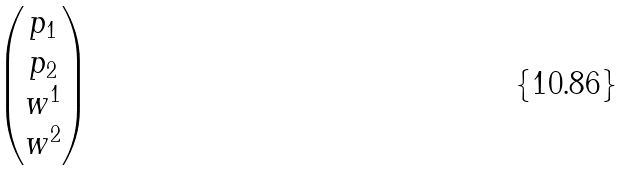Convert formula to latex. <formula><loc_0><loc_0><loc_500><loc_500>\begin{pmatrix} p _ { 1 } \\ p _ { 2 } \\ w ^ { 1 } \\ w ^ { 2 } \\ \end{pmatrix}</formula> 